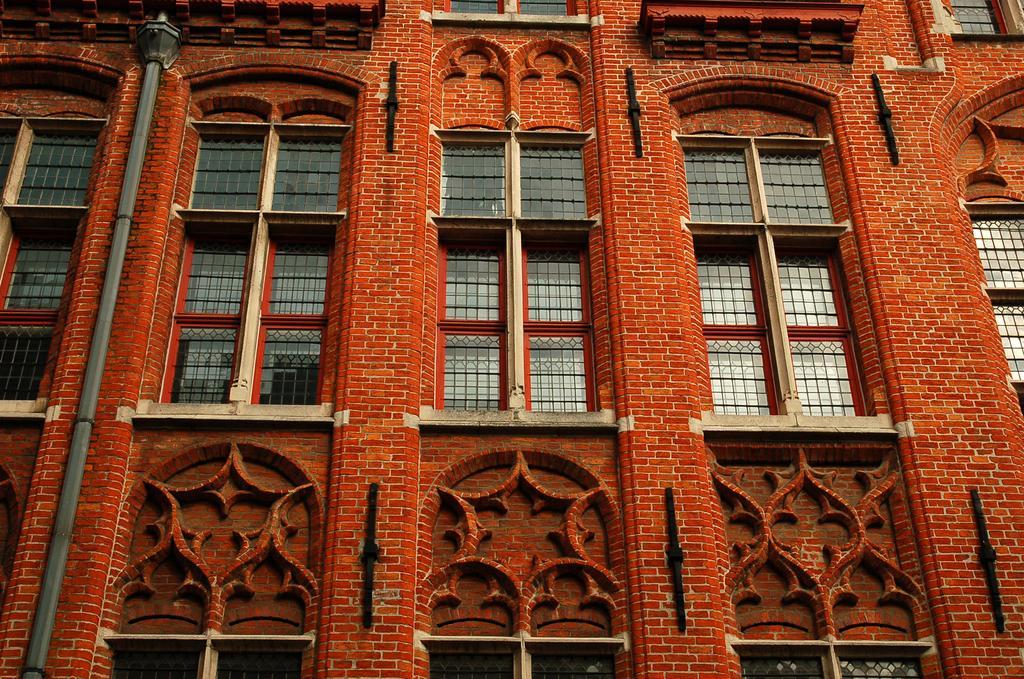Can you describe this image briefly? In the given image i can see a building with windows and light pole. 